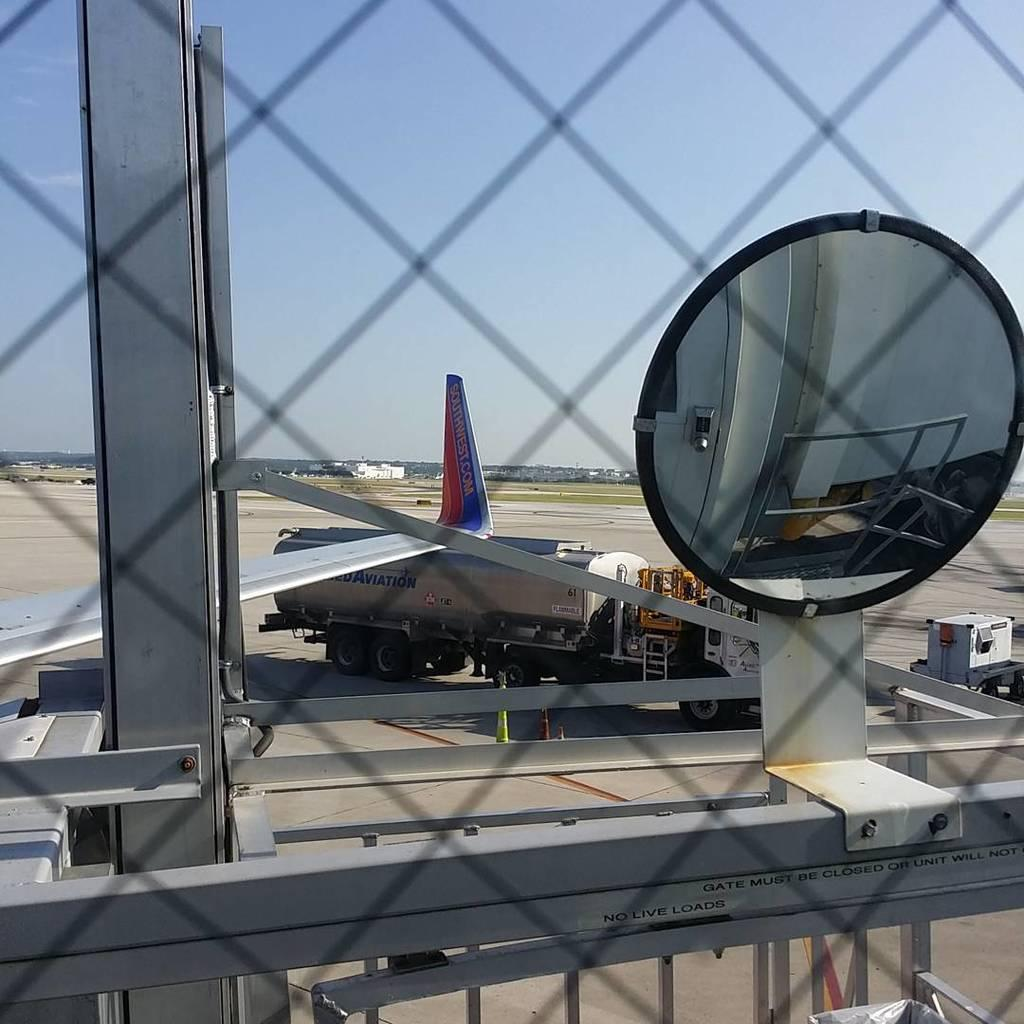<image>
Provide a brief description of the given image. Airplane parked near a truck that says AVIATION on it. 